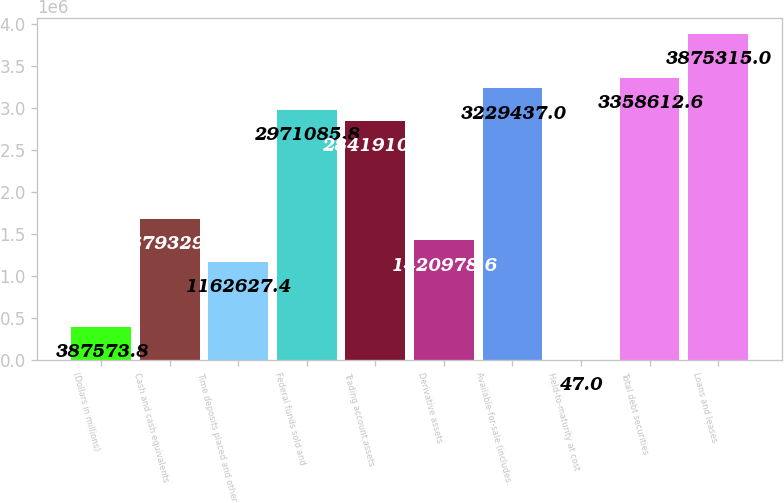<chart> <loc_0><loc_0><loc_500><loc_500><bar_chart><fcel>(Dollars in millions)<fcel>Cash and cash equivalents<fcel>Time deposits placed and other<fcel>Federal funds sold and<fcel>Trading account assets<fcel>Derivative assets<fcel>Available-for-sale (includes<fcel>Held-to-maturity at cost<fcel>Total debt securities<fcel>Loans and leases<nl><fcel>387574<fcel>1.67933e+06<fcel>1.16263e+06<fcel>2.97109e+06<fcel>2.84191e+06<fcel>1.42098e+06<fcel>3.22944e+06<fcel>47<fcel>3.35861e+06<fcel>3.87532e+06<nl></chart> 